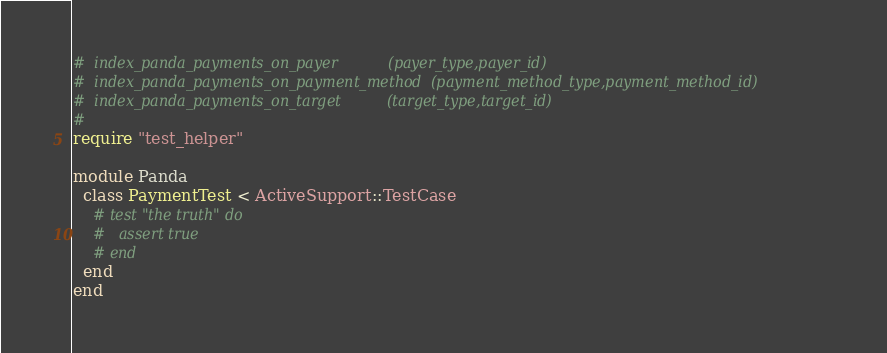<code> <loc_0><loc_0><loc_500><loc_500><_Ruby_>#  index_panda_payments_on_payer           (payer_type,payer_id)
#  index_panda_payments_on_payment_method  (payment_method_type,payment_method_id)
#  index_panda_payments_on_target          (target_type,target_id)
#
require "test_helper"

module Panda
  class PaymentTest < ActiveSupport::TestCase
    # test "the truth" do
    #   assert true
    # end
  end
end
</code> 